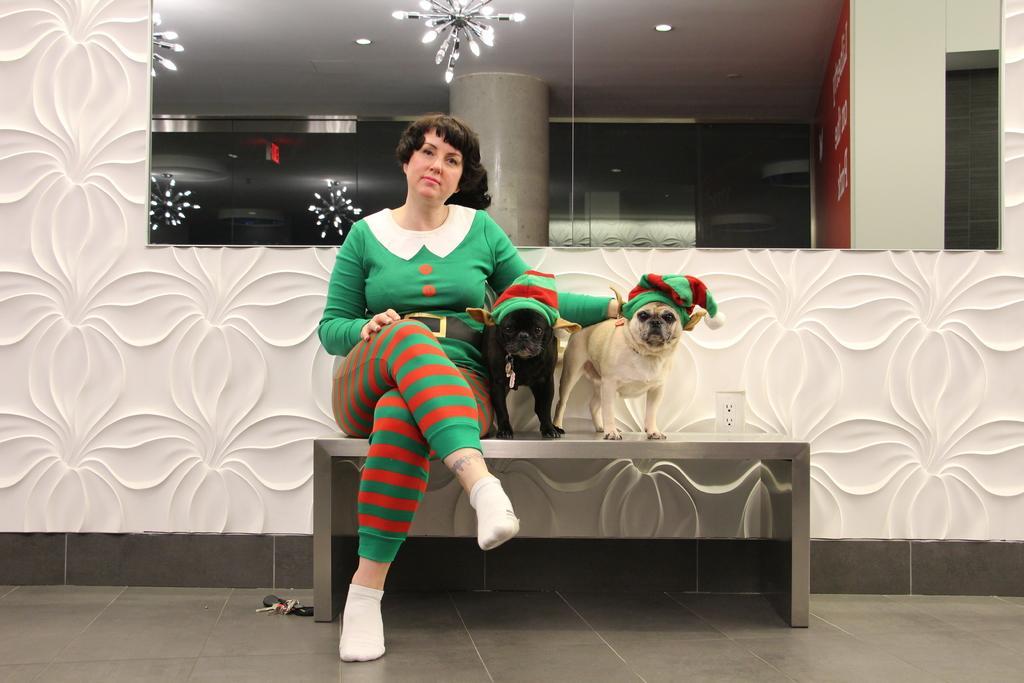Can you describe this image briefly? In this image we can see a woman and two dogs. This is a mirror. 